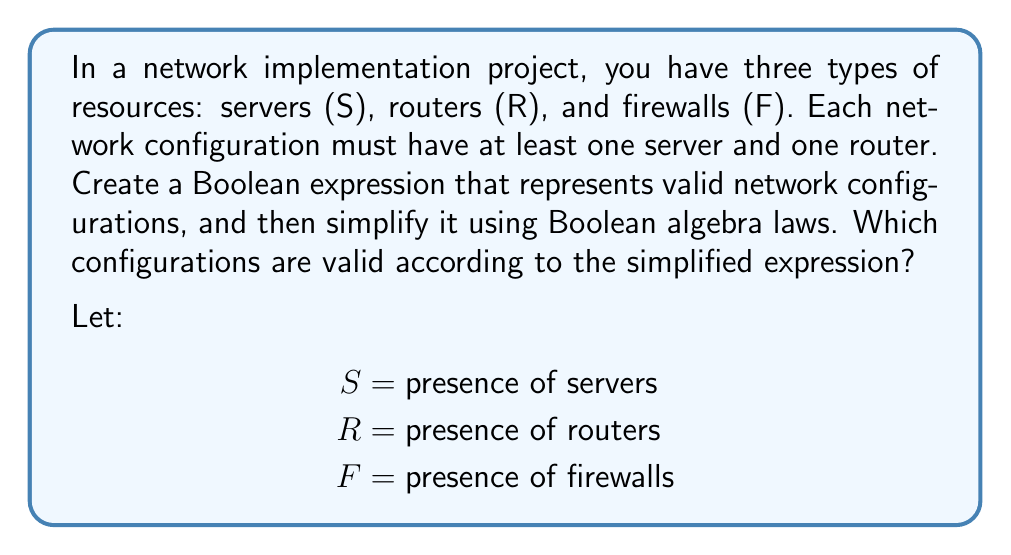Help me with this question. 1. First, we need to create a Boolean expression for valid configurations:
   $$(S \land R)$$
   This expression ensures that both servers and routers are present.

2. To include the optional firewall, we can use the following expression:
   $$(S \land R) \land (F \lor \lnot F)$$

3. Simplify using Boolean algebra laws:
   $$(S \land R) \land (F \lor \lnot F)$$
   $= (S \land R) \land 1$ (Law of Complement: $F \lor \lnot F = 1$)
   $= S \land R$ (Identity Law: $x \land 1 = x$)

4. The simplified expression $S \land R$ means that a valid configuration must have both servers and routers, while firewalls are optional.

5. Valid configurations according to the simplified expression:
   - Servers and routers only (S, R)
   - Servers, routers, and firewalls (S, R, F)

Both configurations satisfy the requirement of having at least one server and one router.
Answer: $S \land R$ 